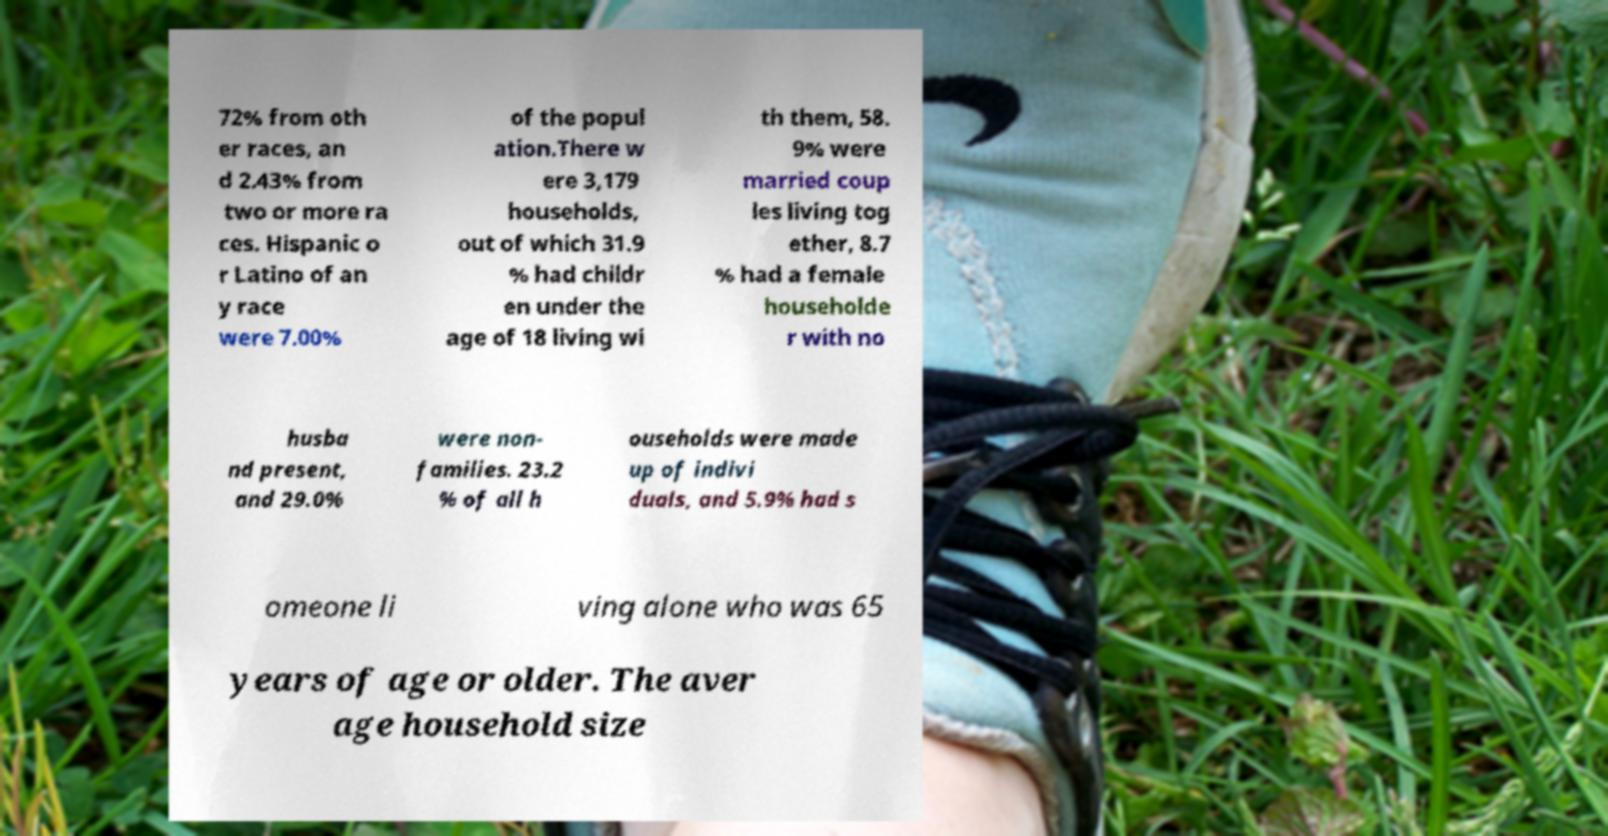What messages or text are displayed in this image? I need them in a readable, typed format. 72% from oth er races, an d 2.43% from two or more ra ces. Hispanic o r Latino of an y race were 7.00% of the popul ation.There w ere 3,179 households, out of which 31.9 % had childr en under the age of 18 living wi th them, 58. 9% were married coup les living tog ether, 8.7 % had a female householde r with no husba nd present, and 29.0% were non- families. 23.2 % of all h ouseholds were made up of indivi duals, and 5.9% had s omeone li ving alone who was 65 years of age or older. The aver age household size 